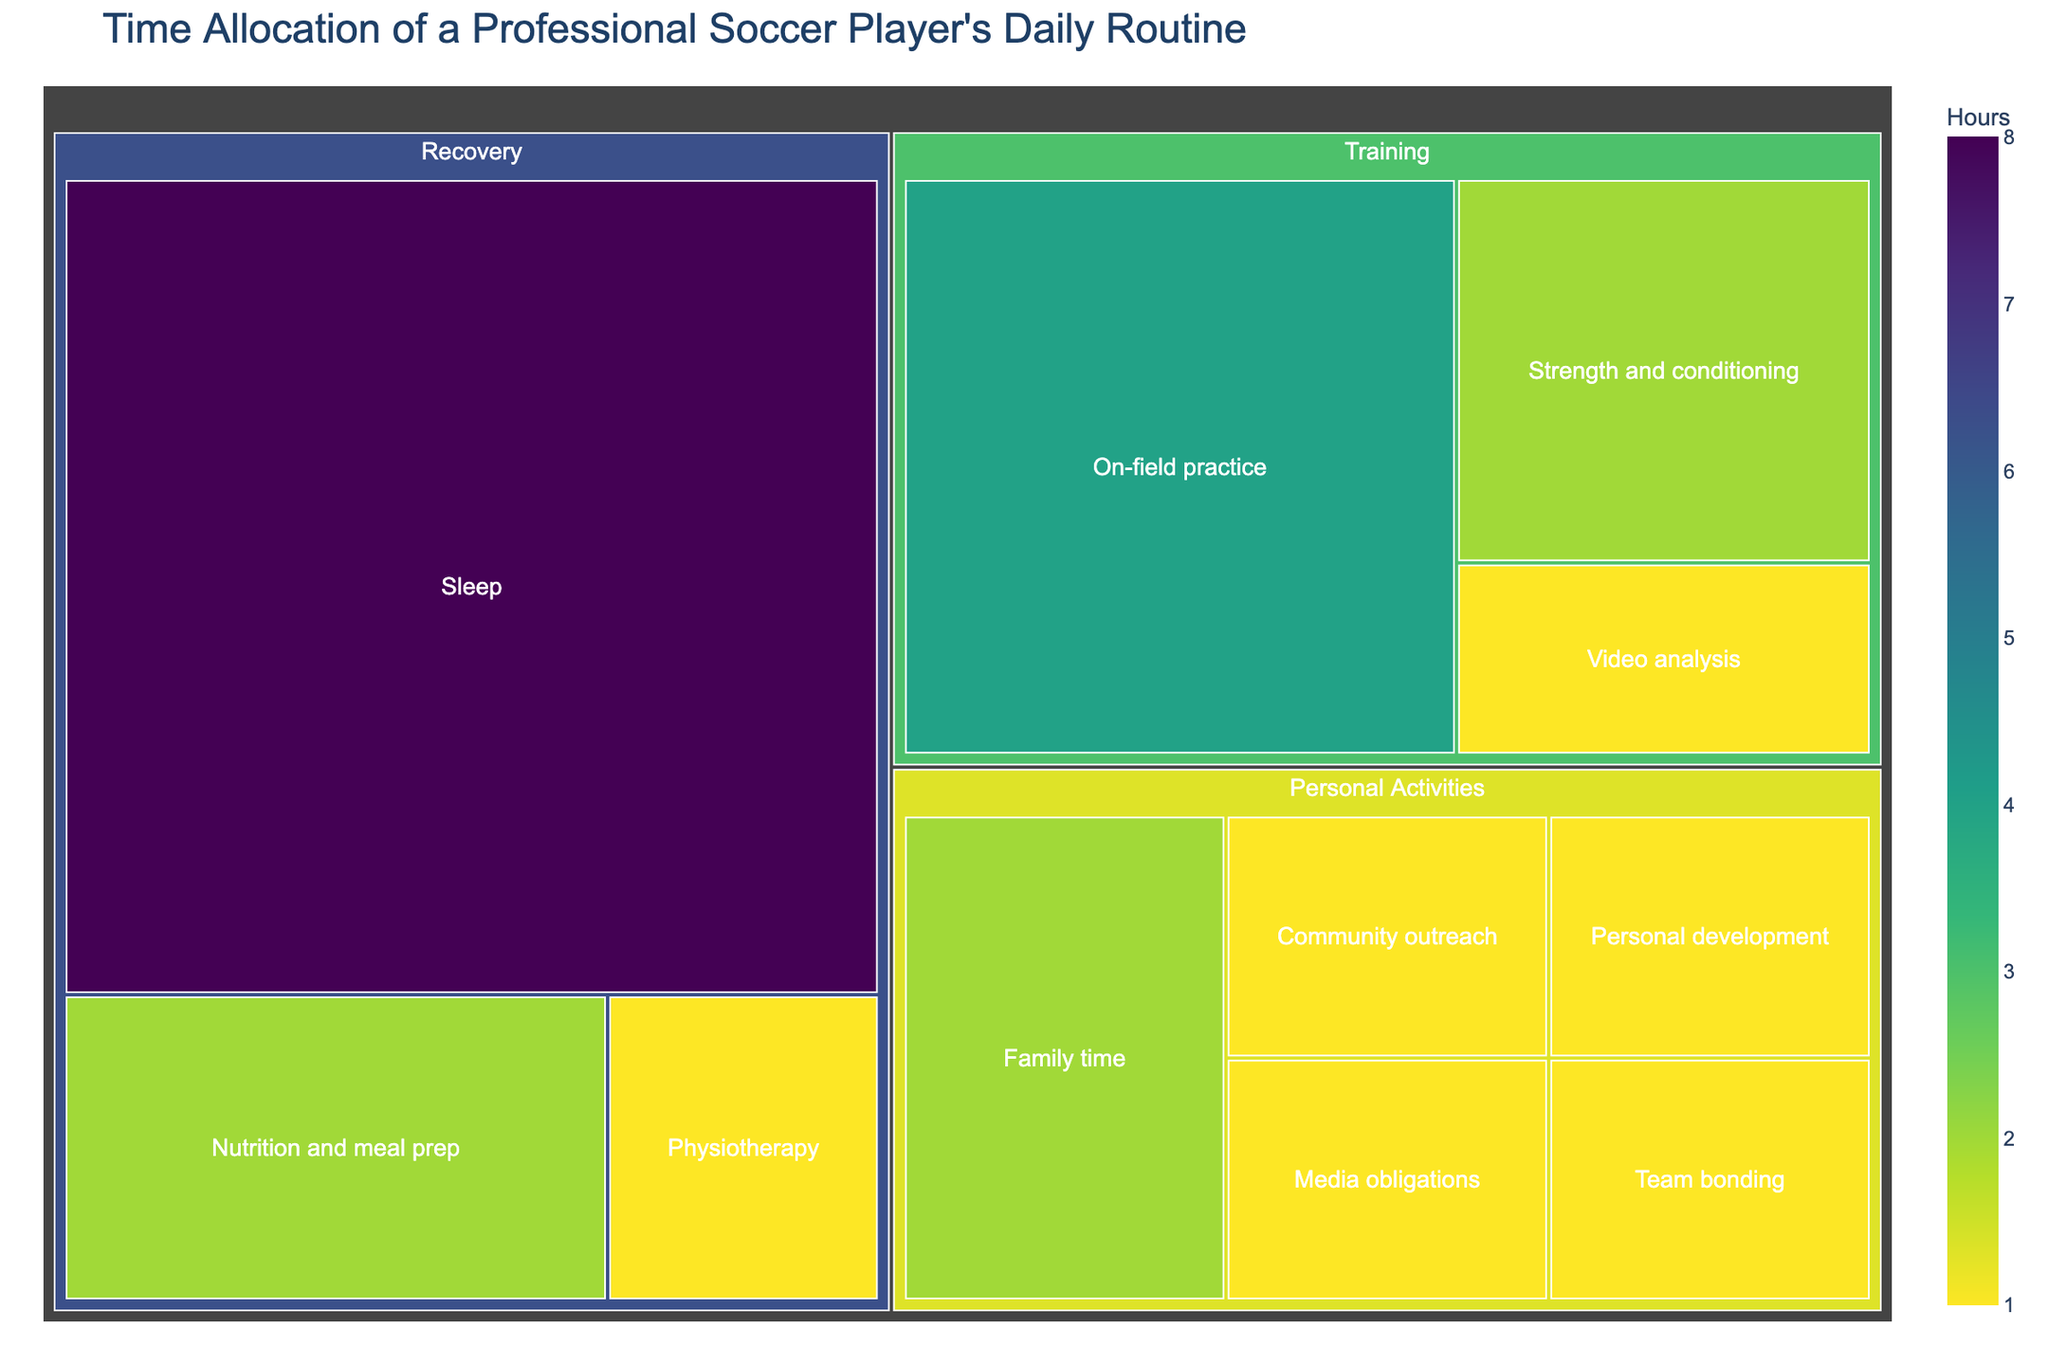What's the title of the treemap? The title is displayed at the top of the figure in a larger font size, indicating the main subject or purpose of the visualization.
Answer: Time Allocation of a Professional Soccer Player's Daily Routine How many main categories are represented in the treemap? By observing the treemap, we can see the main categories which are the largest boxes, and these are subdivided into smaller subcategories.
Answer: Three Which subcategory has the highest number of hours allocated to it? To find this, look for the largest box or the box with the highest value indicated inside it.
Answer: Sleep How many hours per day does the player spend on 'Training'? Sum up the hours of all subcategories under the 'Training' category.
Answer: 7 Which category has more hours allocated: 'Recovery' or 'Personal Activities'? Sum the hours of all subcategories under both 'Recovery' and 'Personal Activities' and compare the totals.
Answer: Recovery What's the total number of hours allocated to 'Personal Activities'? Add up the hours of all subcategories under the 'Personal Activities' category.
Answer: 6 Which has more hours, 'Strength and conditioning' or 'Family time'? Compare the hours values of these two subcategories found under 'Training' and 'Personal Activities', respectively.
Answer: Strength and conditioning How much time is allocated to 'Physiotherapy' and 'Nutrition and meal prep' combined? Add the hours of 'Physiotherapy' and 'Nutrition and meal prep', found under 'Recovery'.
Answer: 3 What's the difference in hours between 'On-field practice' and 'Media obligations'? Subtract the hours of 'Media obligations' from the hours of 'On-field practice'.
Answer: 3 What's the proportion of time allocated to 'Team bonding' compared to the total time spent on 'Training'? Divide the hours of 'Team bonding' by the total hours spent on 'Training' and multiply by 100 to get the percentage.
Answer: ~14.29% 